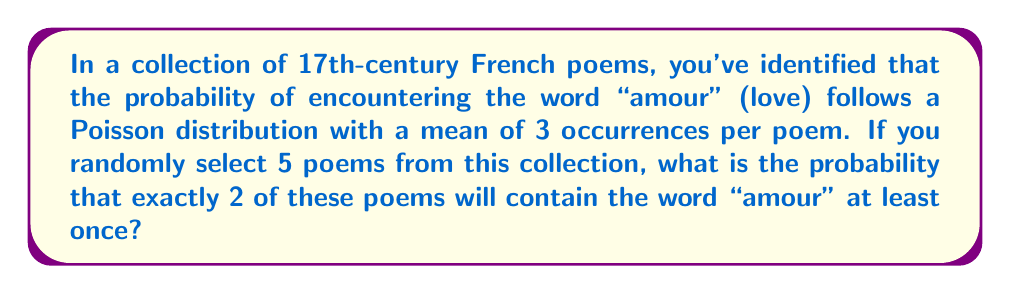Help me with this question. Let's approach this step-by-step:

1) First, we need to calculate the probability of a single poem containing at least one "amour". 
   The probability of 0 occurrences in a Poisson distribution is given by:
   
   $$P(X=0) = e^{-λ} \frac{λ^0}{0!} = e^{-3}$$

   So, the probability of at least one occurrence is:
   
   $$P(X≥1) = 1 - P(X=0) = 1 - e^{-3} ≈ 0.9502$$

2) Now, we have a binomial situation: we're selecting 5 poems, and we want exactly 2 to have the property of containing "amour" at least once.

3) We can use the binomial probability formula:

   $$P(X=k) = \binom{n}{k} p^k (1-p)^{n-k}$$

   Where:
   $n = 5$ (number of poems)
   $k = 2$ (number of successes we want)
   $p = 0.9502$ (probability of success for each poem)

4) Plugging in these values:

   $$P(X=2) = \binom{5}{2} (0.9502)^2 (1-0.9502)^{5-2}$$

5) Calculating:
   
   $$P(X=2) = 10 * (0.9502)^2 * (0.0498)^3 ≈ 0.0036$$

This probability is quite low because it's much more likely that more than 2 poems will contain "amour" at least once, given the high probability for each individual poem.
Answer: 0.0036 